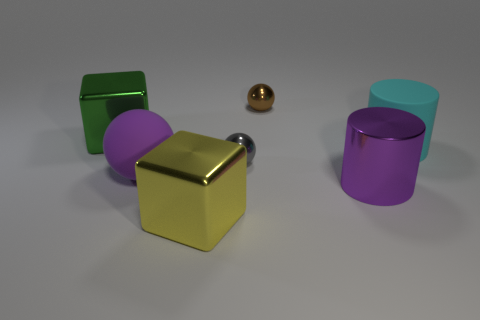Which objects in the picture have reflective surfaces? The golden cylinder and the silver sphere display reflective surfaces that capture the light and surroundings, showcasing mirror-like qualities.  Are these objects illuminated by a single light source? Yes, it appears that a single diffuse light source is illuminating the scene, as evidenced by the soft shadows and consistent highlights on the objects. 